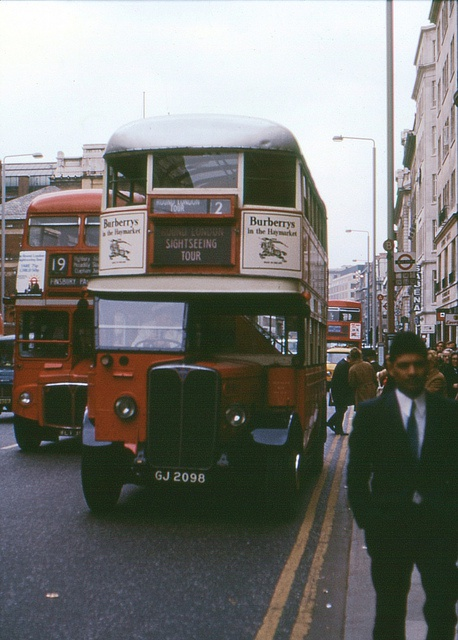Describe the objects in this image and their specific colors. I can see bus in darkgray, black, maroon, and gray tones, people in darkgray, black, and gray tones, bus in darkgray, black, maroon, and gray tones, bus in darkgray, black, gray, and maroon tones, and people in darkgray, gray, and lightgray tones in this image. 